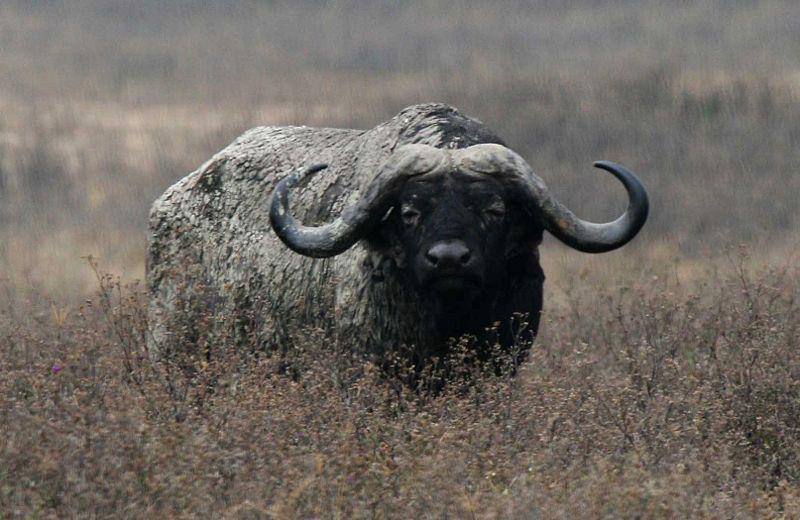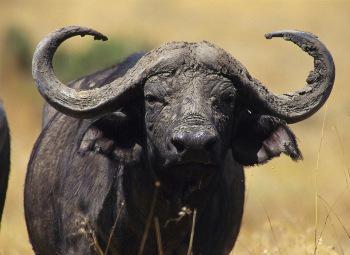The first image is the image on the left, the second image is the image on the right. Assess this claim about the two images: "At least one bird is landing or on a water buffalo.". Correct or not? Answer yes or no. No. The first image is the image on the left, the second image is the image on the right. Analyze the images presented: Is the assertion "An image features a camera-facing water buffalo with a bird perched on it." valid? Answer yes or no. No. 